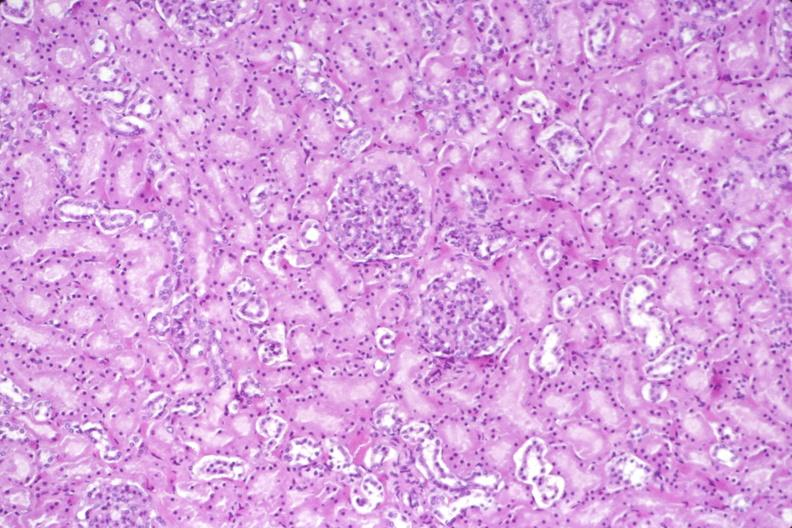what does this image show?
Answer the question using a single word or phrase. Kidney 